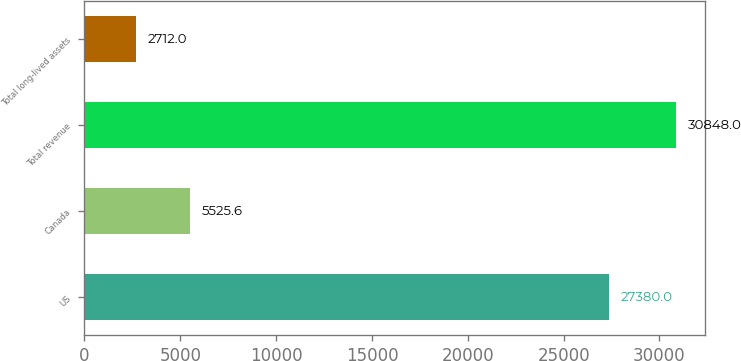<chart> <loc_0><loc_0><loc_500><loc_500><bar_chart><fcel>US<fcel>Canada<fcel>Total revenue<fcel>Total long-lived assets<nl><fcel>27380<fcel>5525.6<fcel>30848<fcel>2712<nl></chart> 